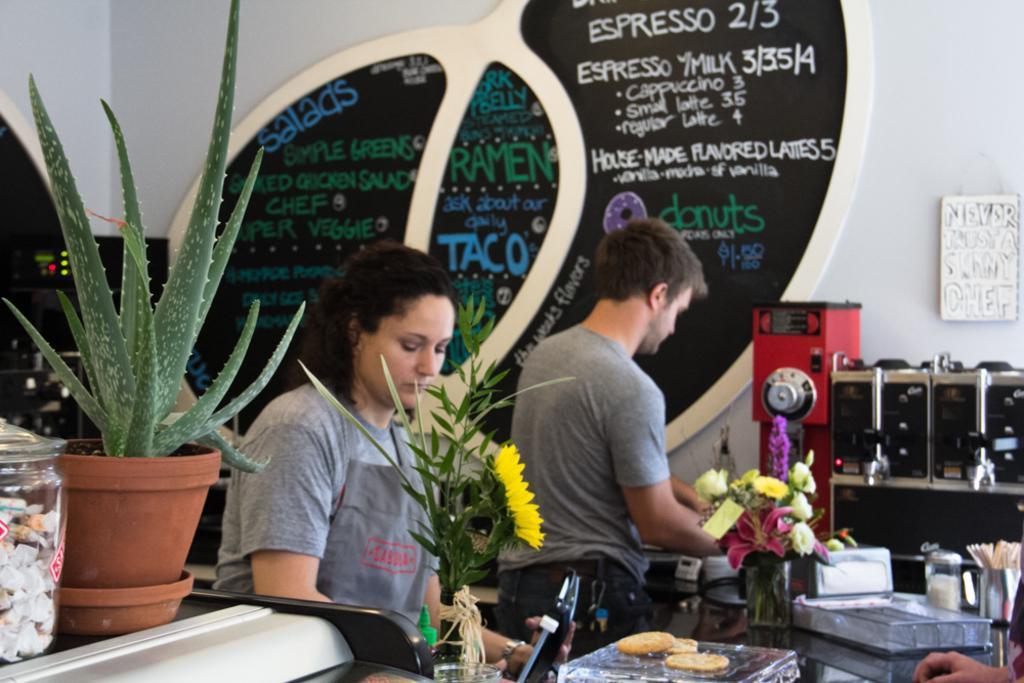Describe this image in one or two sentences. In this picture we can see there are three people standing and in front of the people there are tables and on the tables there are flower vases, transparent boxes, houseplant, jar and some objects. Behind the people there are some machines and a wall with boards. 